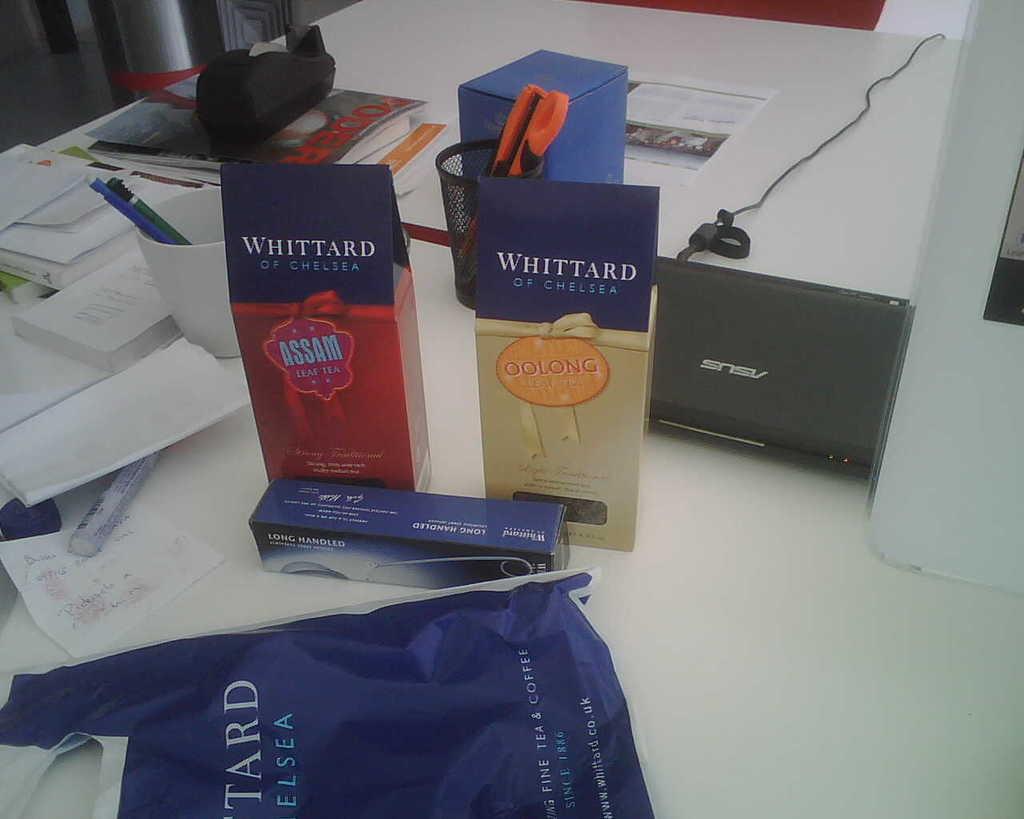What kind of tea is the package on the right?
Ensure brevity in your answer.  Oolong. What kind of tea is the package on the left?
Your answer should be compact. Assam. 